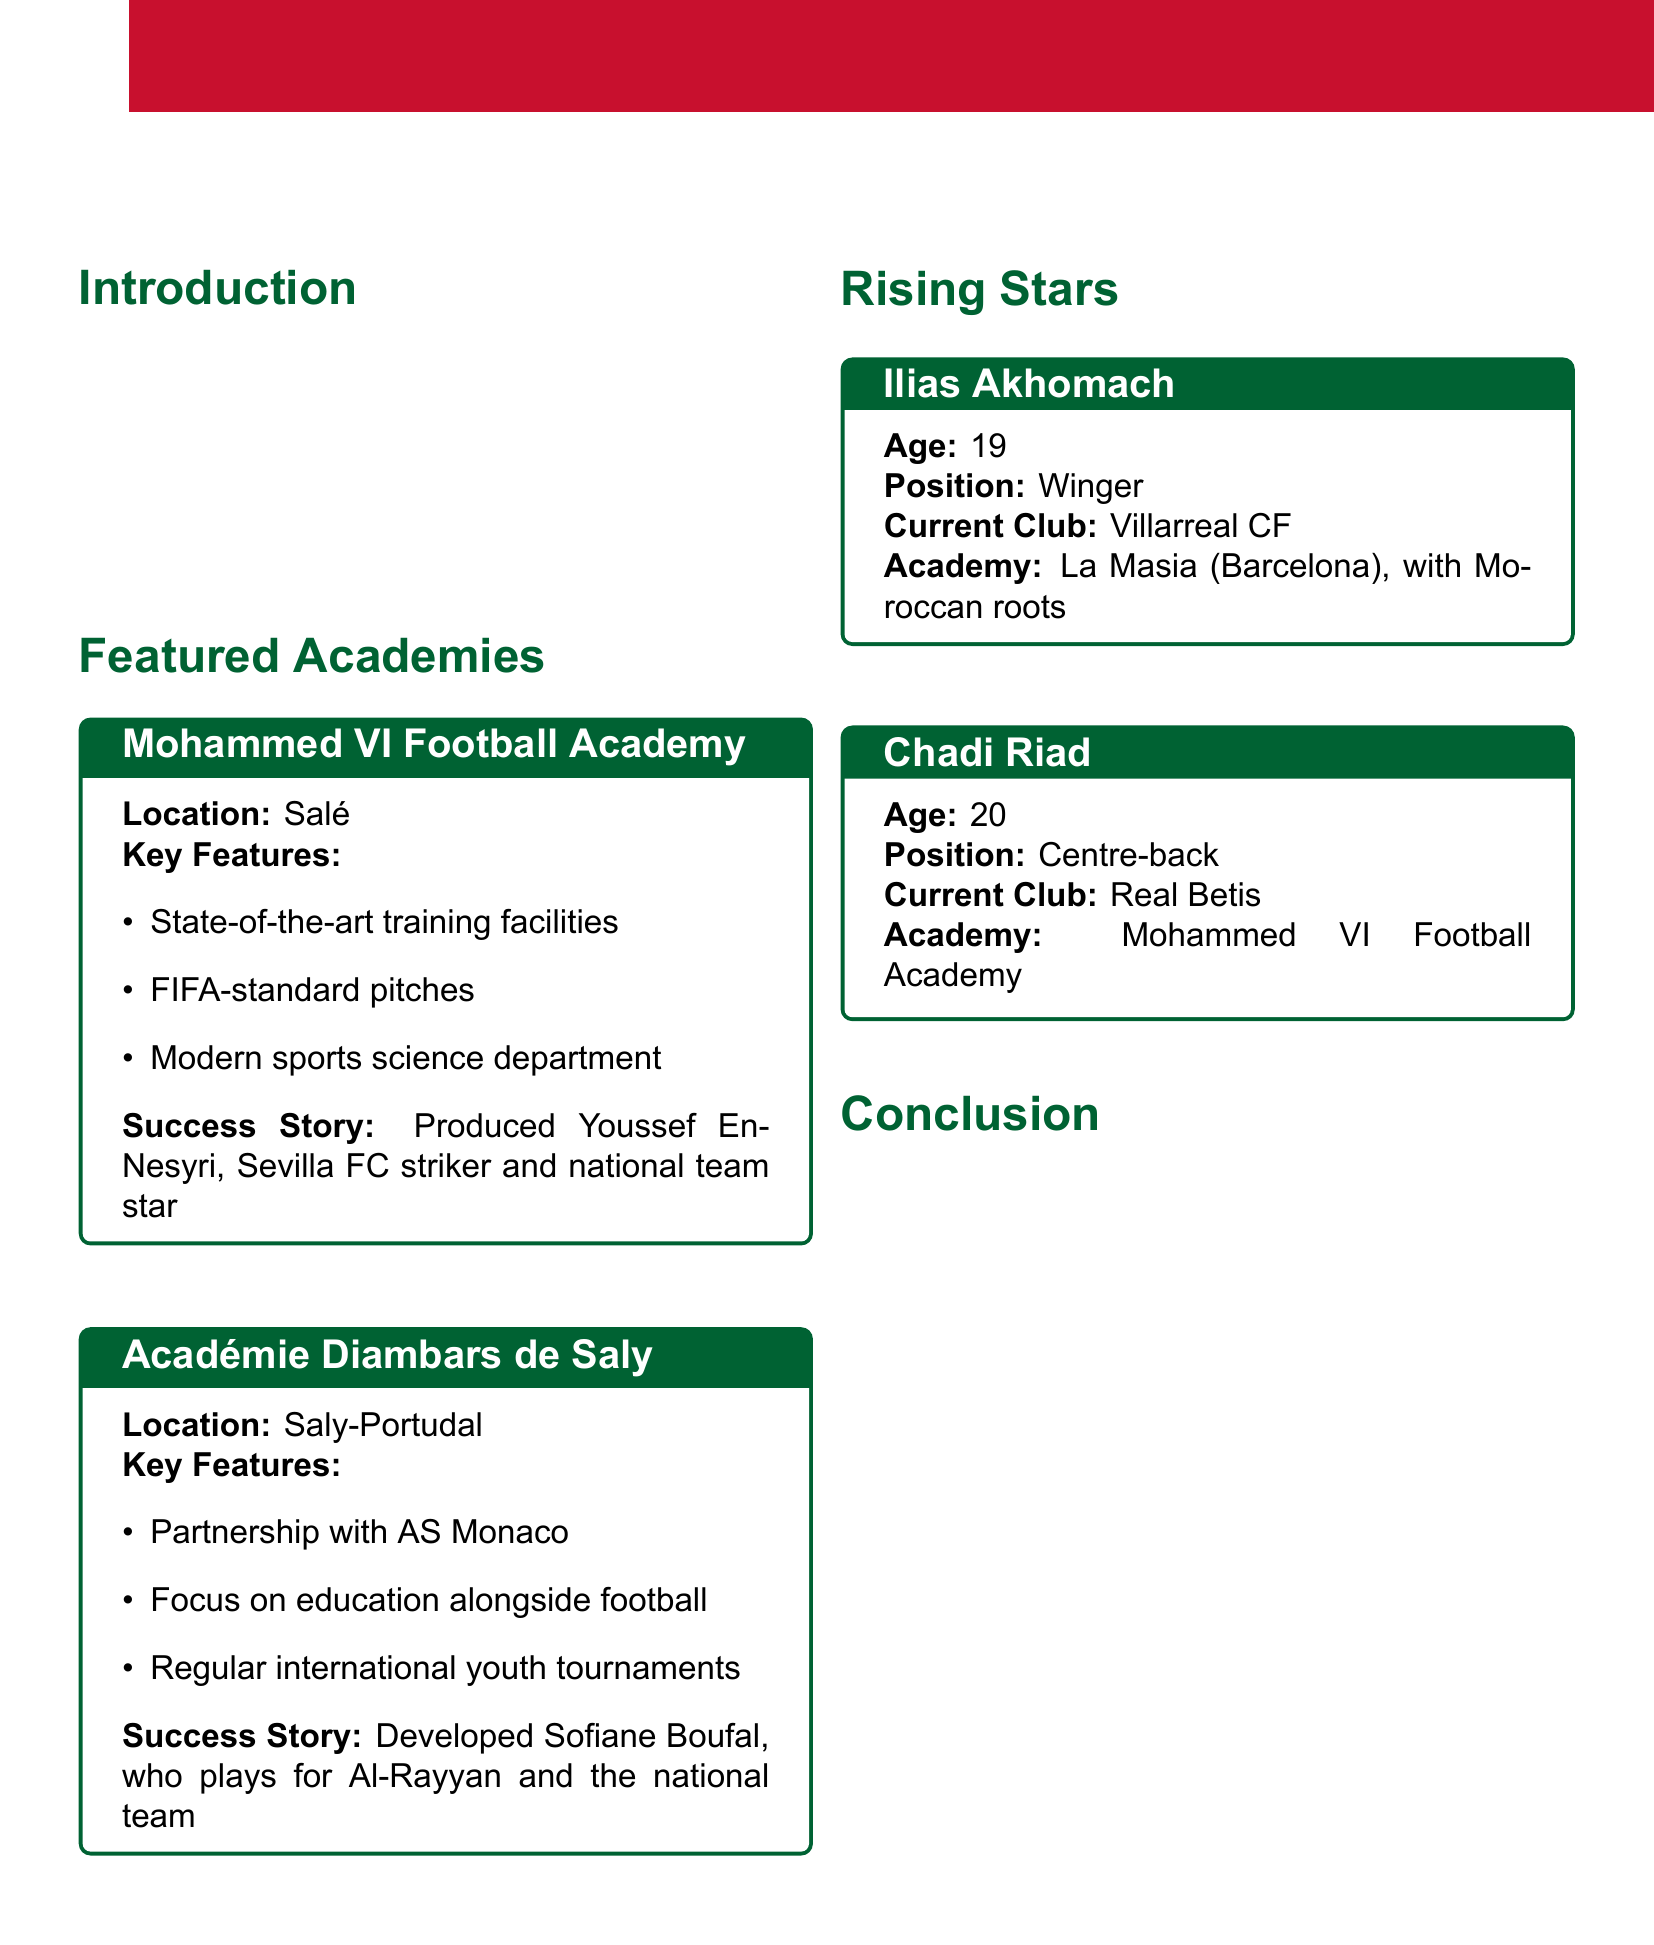what is the location of the Mohammed VI Football Academy? The document specifies that the Mohammed VI Football Academy is located in Salé.
Answer: Salé who is a success story from the Mohammed VI Football Academy? The document mentions that Youssef En-Nesyri is a success story produced by the Mohammed VI Football Academy.
Answer: Youssef En-Nesyri which club does Sofiane Boufal currently play for? According to the document, Sofiane Boufal plays for Al-Rayyan.
Answer: Al-Rayyan what age is Ilias Akhomach? The document states that Ilias Akhomach is 19 years old.
Answer: 19 what is a key feature of the Académie Diambars de Saly? The document highlights that a key feature is its partnership with AS Monaco.
Answer: Partnership with AS Monaco how many players are listed in the Rising Stars section? The document lists two players in the Rising Stars section.
Answer: Two what position does Chadi Riad play? The document specifies that Chadi Riad plays as a centre-back.
Answer: Centre-back which academy is Ilias Akhomach associated with? The document states that Ilias Akhomach is associated with La Masia.
Answer: La Masia what is the main focus of Moroccan football academies as mentioned in the conclusion? The document indicates that these academies are shaping the future of Moroccan football.
Answer: Shaping the future of Moroccan football 